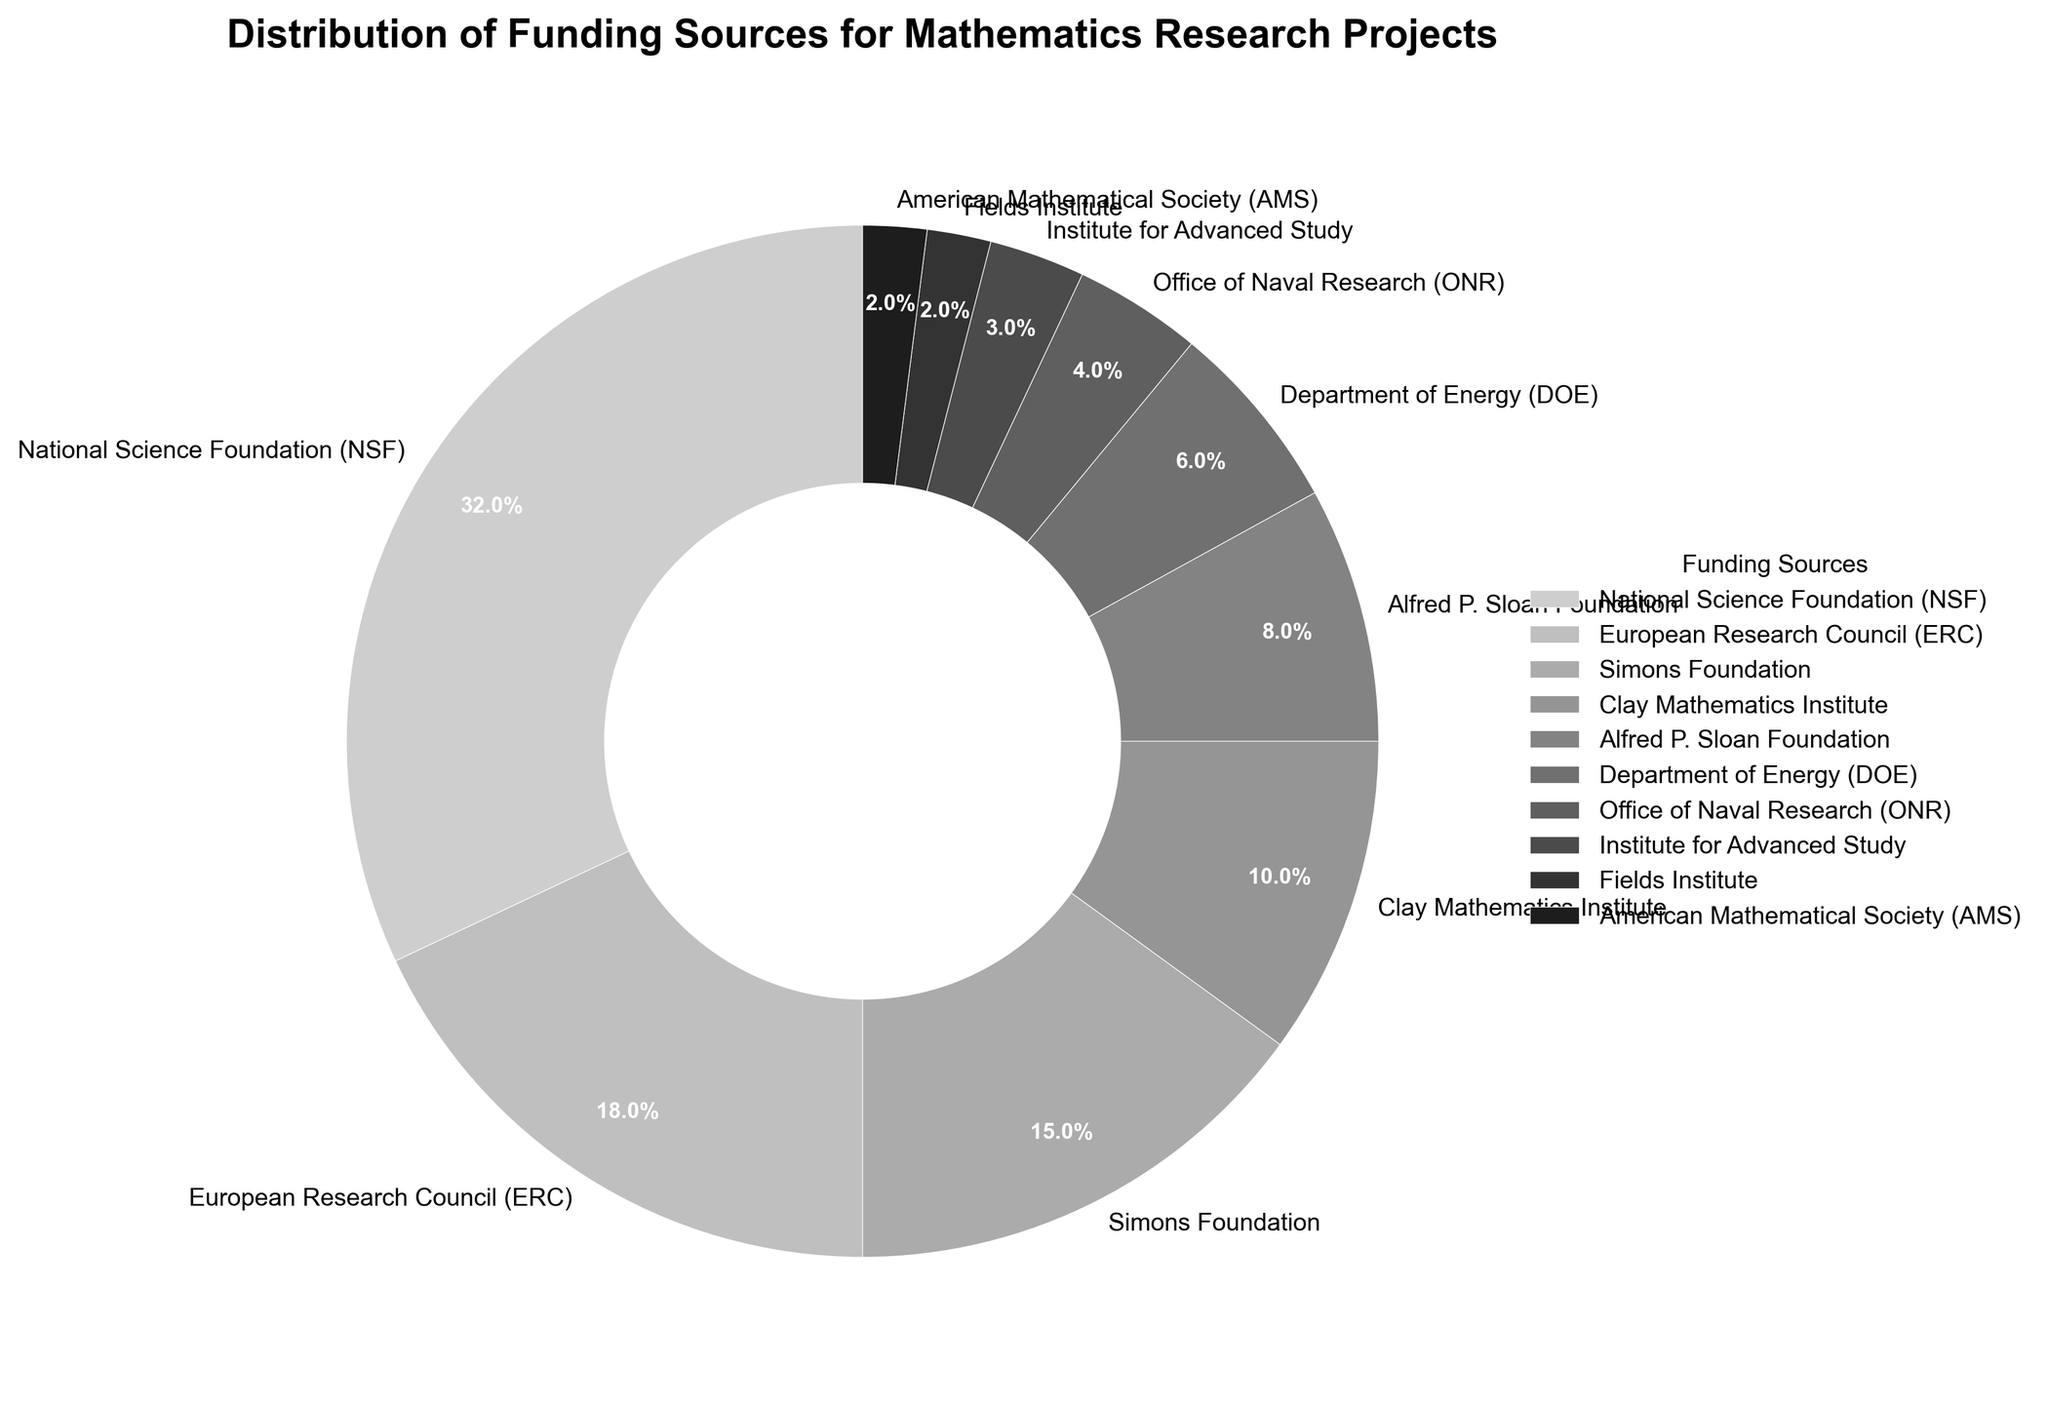What percentage of funding comes from the two largest sources? The two largest sources are the National Science Foundation (32%) and the European Research Council (18%). Adding these percentages together: 32% + 18% = 50%
Answer: 50% Which organization provides more funding, the Simons Foundation or the Department of Energy? The Simons Foundation provides 15% of the funding while the Department of Energy provides 6%. Comparing these two, 15% > 6%
Answer: Simons Foundation What is the combined contribution from the Clay Mathematics Institute and the Alfred P. Sloan Foundation? The Clay Mathematics Institute provides 10% and the Alfred P. Sloan Foundation provides 8%. Adding these percentages together: 10% + 8% = 18%
Answer: 18% Is the funding from the Office of Naval Research greater than the Fields Institute? The Office of Naval Research provides 4% while the Fields Institute provides 2%. Comparing these: 4% > 2%
Answer: Yes What is the difference in funding between the top-funded source and the least-funded source? The top-funded source is the NSF with 32% and the least-funded sources are the Fields Institute and the American Mathematical Society, each with 2%. Subtracting these values: 32% - 2% = 30%
Answer: 30% What is the percentage of funding that comes from sources contributing less than 10% each? Sources contributing less than 10%: Alfred P. Sloan Foundation (8%), Department of Energy (6%), Office of Naval Research (4%), Institute for Advanced Study (3%), Fields Institute (2%), and American Mathematical Society (2%). Adding these percentages: 8% + 6% + 4% + 3% + 2% + 2% = 25%
Answer: 25% Which organization has exactly half the percentage of funding of the NSF? The NSF provides 32%, and half of this is 32% / 2 = 16%. Comparing this to the given data, no organization provides exactly 16% of the funding.
Answer: None Among the Simons Foundation, Department of Energy, and the Office of Naval Research, which has the smallest share of funding? The percentages for the organizations are: Simons Foundation (15%), Department of Energy (6%), Office of Naval Research (4%). The smallest percentage is 4%.
Answer: Office of Naval Research What is the average percentage of funding for the NSF, ERC, and Simons Foundation? The percentages for the NSF, ERC, and Simons Foundation are 32%, 18%, and 15% respectively. The average is calculated as (32% + 18% + 15%) / 3 = 21.67%
Answer: 21.67% How many funding sources contribute at least 10% to mathematics research? Funding sources that contribute at least 10%: NSF (32%), ERC (18%), Simons Foundation (15%), Clay Mathematics Institute (10%). Counting these sources: 4
Answer: 4 